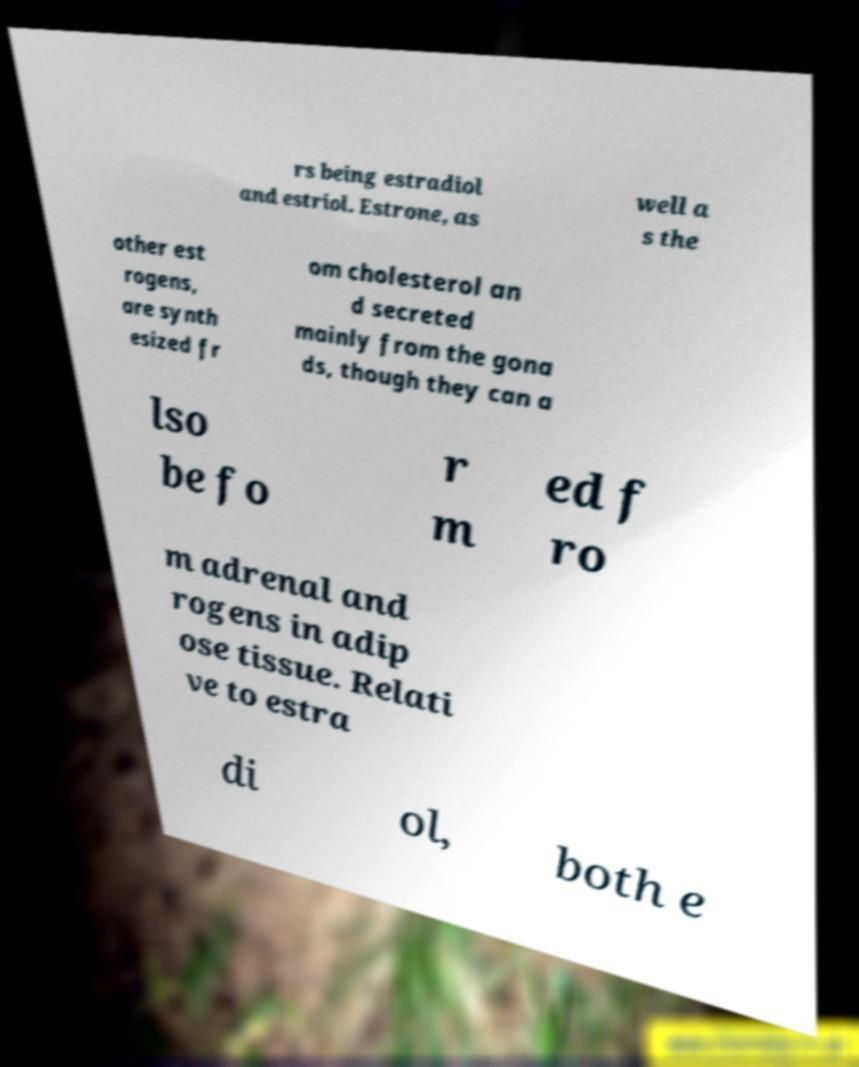Please identify and transcribe the text found in this image. rs being estradiol and estriol. Estrone, as well a s the other est rogens, are synth esized fr om cholesterol an d secreted mainly from the gona ds, though they can a lso be fo r m ed f ro m adrenal and rogens in adip ose tissue. Relati ve to estra di ol, both e 